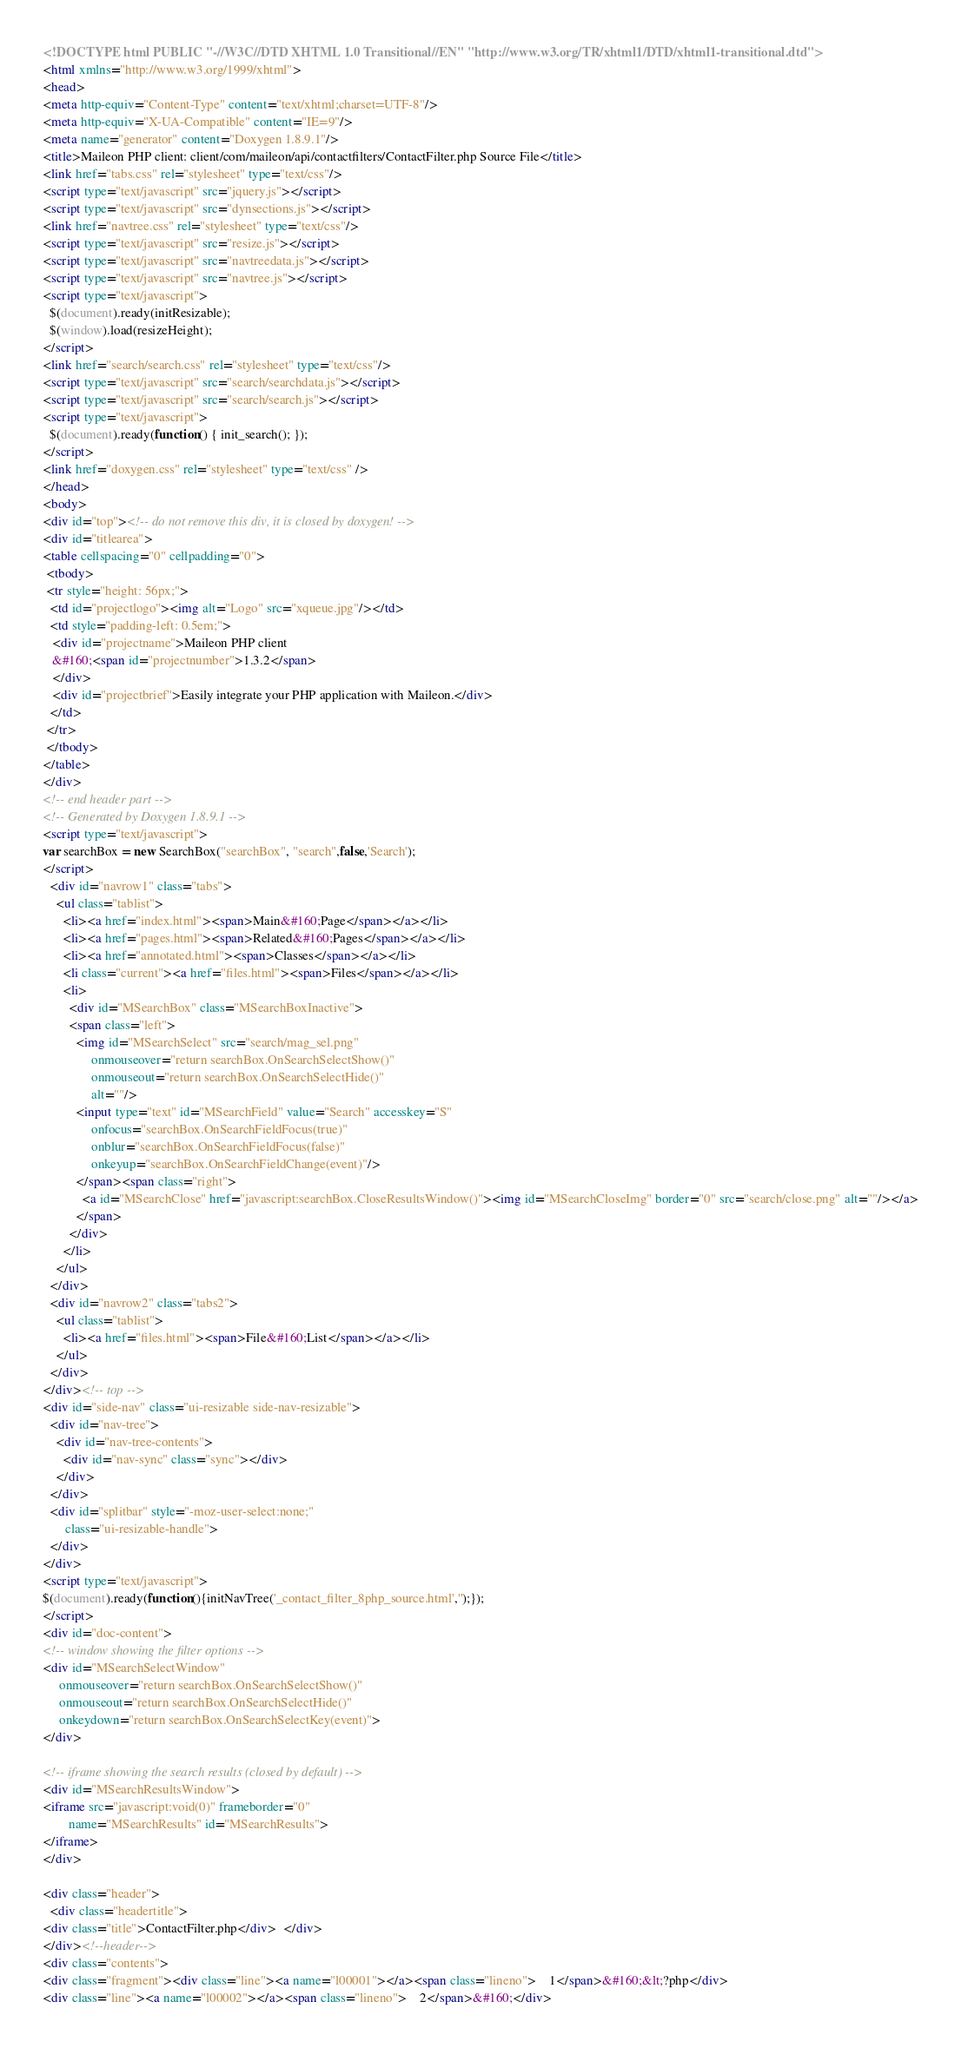<code> <loc_0><loc_0><loc_500><loc_500><_HTML_><!DOCTYPE html PUBLIC "-//W3C//DTD XHTML 1.0 Transitional//EN" "http://www.w3.org/TR/xhtml1/DTD/xhtml1-transitional.dtd">
<html xmlns="http://www.w3.org/1999/xhtml">
<head>
<meta http-equiv="Content-Type" content="text/xhtml;charset=UTF-8"/>
<meta http-equiv="X-UA-Compatible" content="IE=9"/>
<meta name="generator" content="Doxygen 1.8.9.1"/>
<title>Maileon PHP client: client/com/maileon/api/contactfilters/ContactFilter.php Source File</title>
<link href="tabs.css" rel="stylesheet" type="text/css"/>
<script type="text/javascript" src="jquery.js"></script>
<script type="text/javascript" src="dynsections.js"></script>
<link href="navtree.css" rel="stylesheet" type="text/css"/>
<script type="text/javascript" src="resize.js"></script>
<script type="text/javascript" src="navtreedata.js"></script>
<script type="text/javascript" src="navtree.js"></script>
<script type="text/javascript">
  $(document).ready(initResizable);
  $(window).load(resizeHeight);
</script>
<link href="search/search.css" rel="stylesheet" type="text/css"/>
<script type="text/javascript" src="search/searchdata.js"></script>
<script type="text/javascript" src="search/search.js"></script>
<script type="text/javascript">
  $(document).ready(function() { init_search(); });
</script>
<link href="doxygen.css" rel="stylesheet" type="text/css" />
</head>
<body>
<div id="top"><!-- do not remove this div, it is closed by doxygen! -->
<div id="titlearea">
<table cellspacing="0" cellpadding="0">
 <tbody>
 <tr style="height: 56px;">
  <td id="projectlogo"><img alt="Logo" src="xqueue.jpg"/></td>
  <td style="padding-left: 0.5em;">
   <div id="projectname">Maileon PHP client
   &#160;<span id="projectnumber">1.3.2</span>
   </div>
   <div id="projectbrief">Easily integrate your PHP application with Maileon.</div>
  </td>
 </tr>
 </tbody>
</table>
</div>
<!-- end header part -->
<!-- Generated by Doxygen 1.8.9.1 -->
<script type="text/javascript">
var searchBox = new SearchBox("searchBox", "search",false,'Search');
</script>
  <div id="navrow1" class="tabs">
    <ul class="tablist">
      <li><a href="index.html"><span>Main&#160;Page</span></a></li>
      <li><a href="pages.html"><span>Related&#160;Pages</span></a></li>
      <li><a href="annotated.html"><span>Classes</span></a></li>
      <li class="current"><a href="files.html"><span>Files</span></a></li>
      <li>
        <div id="MSearchBox" class="MSearchBoxInactive">
        <span class="left">
          <img id="MSearchSelect" src="search/mag_sel.png"
               onmouseover="return searchBox.OnSearchSelectShow()"
               onmouseout="return searchBox.OnSearchSelectHide()"
               alt=""/>
          <input type="text" id="MSearchField" value="Search" accesskey="S"
               onfocus="searchBox.OnSearchFieldFocus(true)" 
               onblur="searchBox.OnSearchFieldFocus(false)" 
               onkeyup="searchBox.OnSearchFieldChange(event)"/>
          </span><span class="right">
            <a id="MSearchClose" href="javascript:searchBox.CloseResultsWindow()"><img id="MSearchCloseImg" border="0" src="search/close.png" alt=""/></a>
          </span>
        </div>
      </li>
    </ul>
  </div>
  <div id="navrow2" class="tabs2">
    <ul class="tablist">
      <li><a href="files.html"><span>File&#160;List</span></a></li>
    </ul>
  </div>
</div><!-- top -->
<div id="side-nav" class="ui-resizable side-nav-resizable">
  <div id="nav-tree">
    <div id="nav-tree-contents">
      <div id="nav-sync" class="sync"></div>
    </div>
  </div>
  <div id="splitbar" style="-moz-user-select:none;" 
       class="ui-resizable-handle">
  </div>
</div>
<script type="text/javascript">
$(document).ready(function(){initNavTree('_contact_filter_8php_source.html','');});
</script>
<div id="doc-content">
<!-- window showing the filter options -->
<div id="MSearchSelectWindow"
     onmouseover="return searchBox.OnSearchSelectShow()"
     onmouseout="return searchBox.OnSearchSelectHide()"
     onkeydown="return searchBox.OnSearchSelectKey(event)">
</div>

<!-- iframe showing the search results (closed by default) -->
<div id="MSearchResultsWindow">
<iframe src="javascript:void(0)" frameborder="0" 
        name="MSearchResults" id="MSearchResults">
</iframe>
</div>

<div class="header">
  <div class="headertitle">
<div class="title">ContactFilter.php</div>  </div>
</div><!--header-->
<div class="contents">
<div class="fragment"><div class="line"><a name="l00001"></a><span class="lineno">    1</span>&#160;&lt;?php</div>
<div class="line"><a name="l00002"></a><span class="lineno">    2</span>&#160;</div></code> 